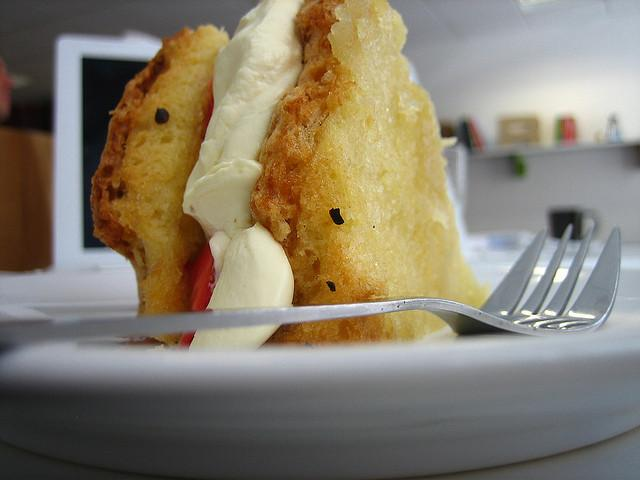What type of fork is included with the meal?

Choices:
A) dessert
B) fruit
C) baby
D) salad dessert 